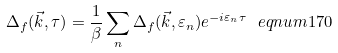<formula> <loc_0><loc_0><loc_500><loc_500>\Delta _ { f } ( \vec { k } , \tau ) = \frac { 1 } { \beta } \sum _ { n } \Delta _ { f } ( \vec { k } , \varepsilon _ { n } ) e ^ { - i \varepsilon _ { n } \tau } \ e q n u m { 1 7 0 }</formula> 